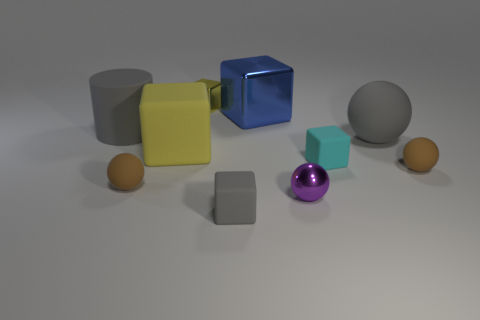Subtract all yellow matte blocks. How many blocks are left? 4 Subtract all purple balls. How many balls are left? 3 Subtract 1 cylinders. How many cylinders are left? 0 Subtract all red spheres. Subtract all cyan cubes. How many spheres are left? 4 Subtract all brown cylinders. How many purple spheres are left? 1 Subtract all tiny gray cubes. Subtract all blue cubes. How many objects are left? 8 Add 1 small yellow shiny cubes. How many small yellow shiny cubes are left? 2 Add 6 big red shiny blocks. How many big red shiny blocks exist? 6 Subtract 0 purple cubes. How many objects are left? 10 Subtract all balls. How many objects are left? 6 